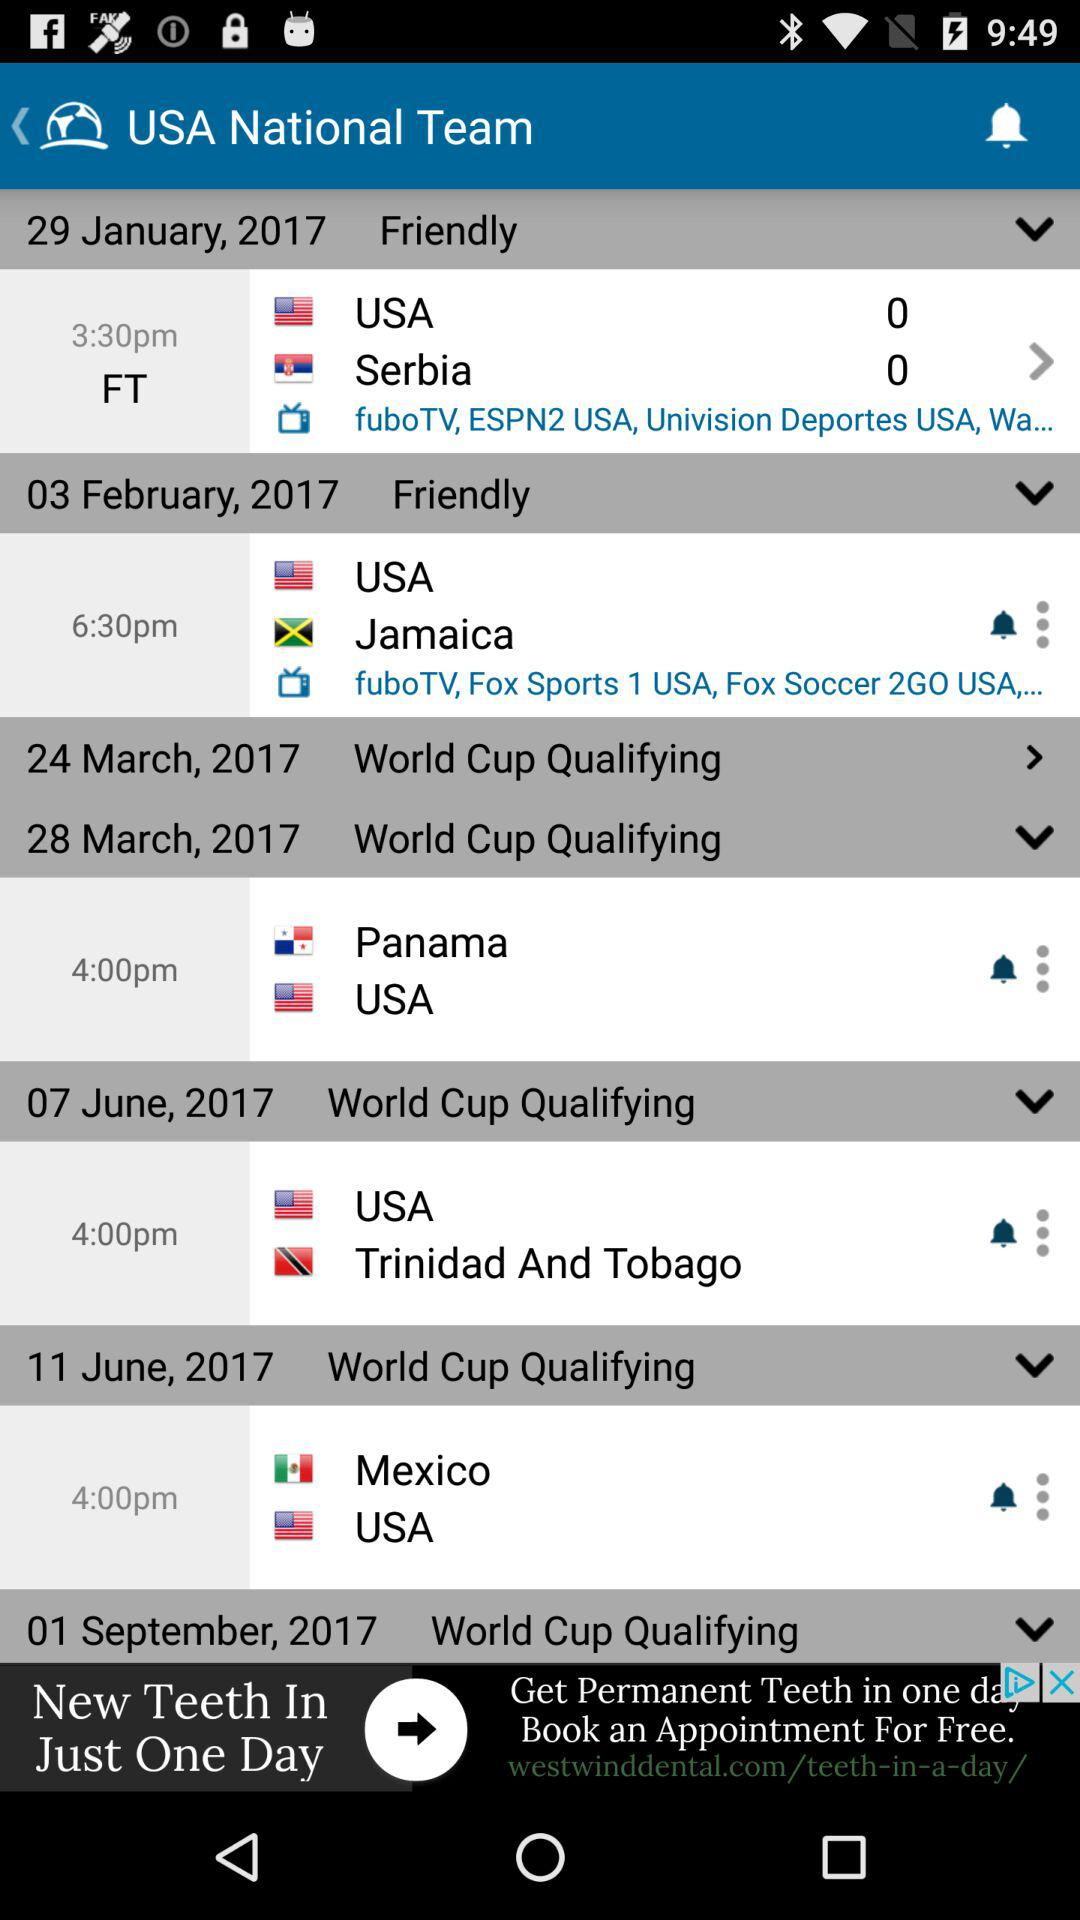Which teams are competing on June 11th, 2017? The competing teams are "Mexico" and "USA". 